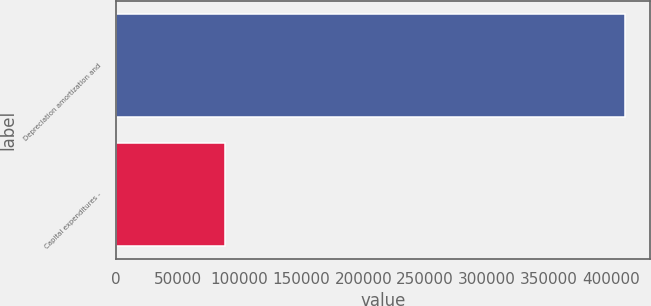Convert chart. <chart><loc_0><loc_0><loc_500><loc_500><bar_chart><fcel>Depreciation amortization and<fcel>Capital expenditures -<nl><fcel>411254<fcel>88637<nl></chart> 